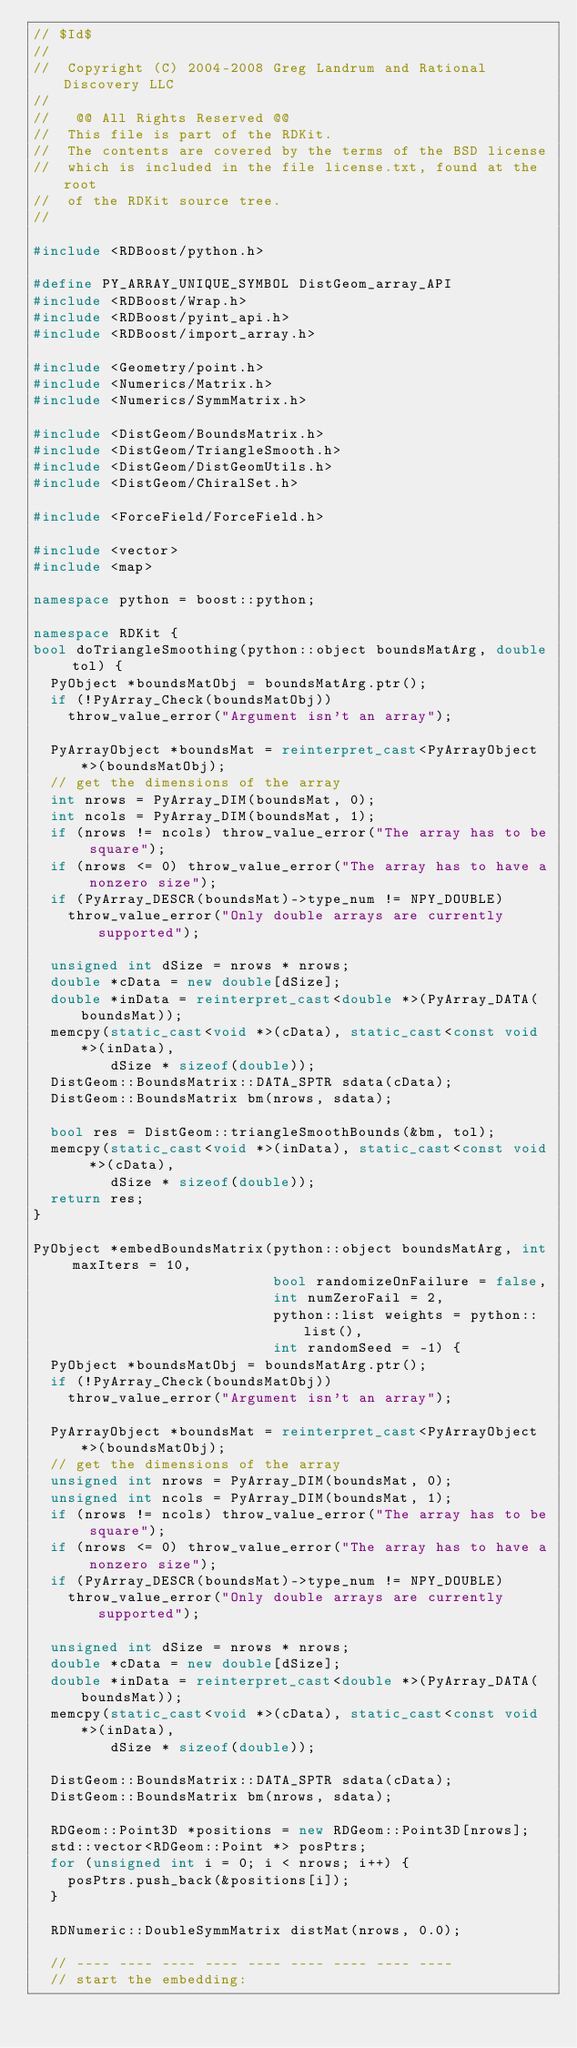<code> <loc_0><loc_0><loc_500><loc_500><_C++_>// $Id$
//
//  Copyright (C) 2004-2008 Greg Landrum and Rational Discovery LLC
//
//   @@ All Rights Reserved @@
//  This file is part of the RDKit.
//  The contents are covered by the terms of the BSD license
//  which is included in the file license.txt, found at the root
//  of the RDKit source tree.
//

#include <RDBoost/python.h>

#define PY_ARRAY_UNIQUE_SYMBOL DistGeom_array_API
#include <RDBoost/Wrap.h>
#include <RDBoost/pyint_api.h>
#include <RDBoost/import_array.h>

#include <Geometry/point.h>
#include <Numerics/Matrix.h>
#include <Numerics/SymmMatrix.h>

#include <DistGeom/BoundsMatrix.h>
#include <DistGeom/TriangleSmooth.h>
#include <DistGeom/DistGeomUtils.h>
#include <DistGeom/ChiralSet.h>

#include <ForceField/ForceField.h>

#include <vector>
#include <map>

namespace python = boost::python;

namespace RDKit {
bool doTriangleSmoothing(python::object boundsMatArg, double tol) {
  PyObject *boundsMatObj = boundsMatArg.ptr();
  if (!PyArray_Check(boundsMatObj))
    throw_value_error("Argument isn't an array");

  PyArrayObject *boundsMat = reinterpret_cast<PyArrayObject *>(boundsMatObj);
  // get the dimensions of the array
  int nrows = PyArray_DIM(boundsMat, 0);
  int ncols = PyArray_DIM(boundsMat, 1);
  if (nrows != ncols) throw_value_error("The array has to be square");
  if (nrows <= 0) throw_value_error("The array has to have a nonzero size");
  if (PyArray_DESCR(boundsMat)->type_num != NPY_DOUBLE)
    throw_value_error("Only double arrays are currently supported");

  unsigned int dSize = nrows * nrows;
  double *cData = new double[dSize];
  double *inData = reinterpret_cast<double *>(PyArray_DATA(boundsMat));
  memcpy(static_cast<void *>(cData), static_cast<const void *>(inData),
         dSize * sizeof(double));
  DistGeom::BoundsMatrix::DATA_SPTR sdata(cData);
  DistGeom::BoundsMatrix bm(nrows, sdata);

  bool res = DistGeom::triangleSmoothBounds(&bm, tol);
  memcpy(static_cast<void *>(inData), static_cast<const void *>(cData),
         dSize * sizeof(double));
  return res;
}

PyObject *embedBoundsMatrix(python::object boundsMatArg, int maxIters = 10,
                            bool randomizeOnFailure = false,
                            int numZeroFail = 2,
                            python::list weights = python::list(),
                            int randomSeed = -1) {
  PyObject *boundsMatObj = boundsMatArg.ptr();
  if (!PyArray_Check(boundsMatObj))
    throw_value_error("Argument isn't an array");

  PyArrayObject *boundsMat = reinterpret_cast<PyArrayObject *>(boundsMatObj);
  // get the dimensions of the array
  unsigned int nrows = PyArray_DIM(boundsMat, 0);
  unsigned int ncols = PyArray_DIM(boundsMat, 1);
  if (nrows != ncols) throw_value_error("The array has to be square");
  if (nrows <= 0) throw_value_error("The array has to have a nonzero size");
  if (PyArray_DESCR(boundsMat)->type_num != NPY_DOUBLE)
    throw_value_error("Only double arrays are currently supported");

  unsigned int dSize = nrows * nrows;
  double *cData = new double[dSize];
  double *inData = reinterpret_cast<double *>(PyArray_DATA(boundsMat));
  memcpy(static_cast<void *>(cData), static_cast<const void *>(inData),
         dSize * sizeof(double));

  DistGeom::BoundsMatrix::DATA_SPTR sdata(cData);
  DistGeom::BoundsMatrix bm(nrows, sdata);

  RDGeom::Point3D *positions = new RDGeom::Point3D[nrows];
  std::vector<RDGeom::Point *> posPtrs;
  for (unsigned int i = 0; i < nrows; i++) {
    posPtrs.push_back(&positions[i]);
  }

  RDNumeric::DoubleSymmMatrix distMat(nrows, 0.0);

  // ---- ---- ---- ---- ---- ---- ---- ---- ----
  // start the embedding:</code> 